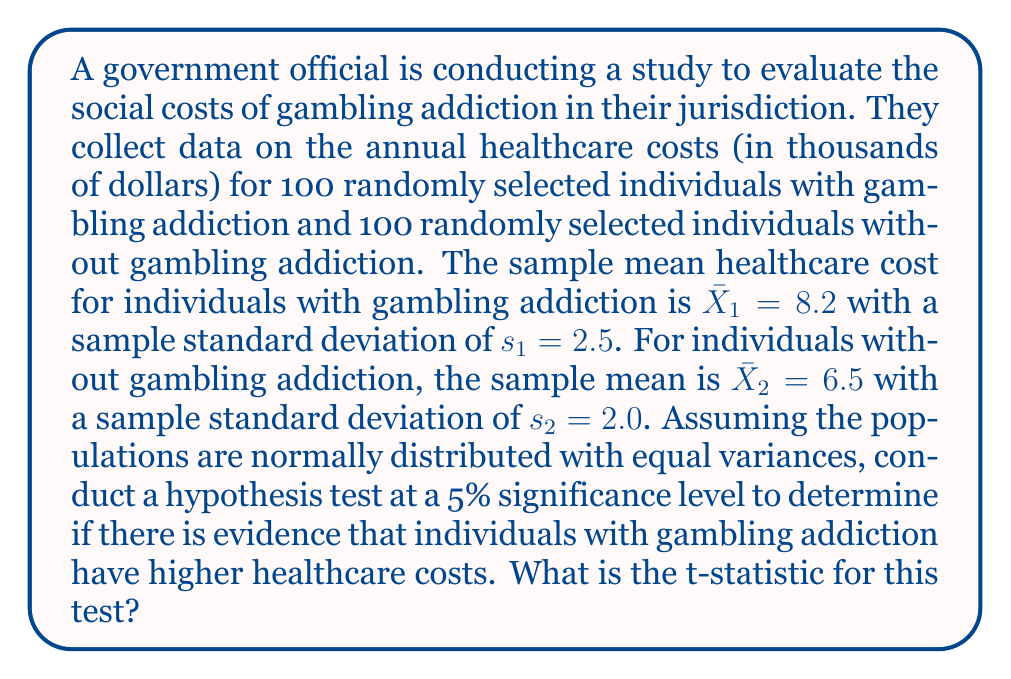Help me with this question. To conduct this hypothesis test, we'll follow these steps:

1) First, let's state our hypotheses:
   $H_0: \mu_1 - \mu_2 = 0$ (There's no difference in healthcare costs)
   $H_a: \mu_1 - \mu_2 > 0$ (Healthcare costs are higher for individuals with gambling addiction)

2) We'll use a two-sample t-test with pooled variance, as we're assuming equal population variances.

3) The formula for the t-statistic is:

   $$t = \frac{(\bar{X}_1 - \bar{X}_2) - (\mu_1 - \mu_2)_0}{\sqrt{s_p^2(\frac{1}{n_1} + \frac{1}{n_2})}}$$

   Where $s_p^2$ is the pooled variance:

   $$s_p^2 = \frac{(n_1 - 1)s_1^2 + (n_2 - 1)s_2^2}{n_1 + n_2 - 2}$$

4) Let's calculate the pooled variance:

   $$s_p^2 = \frac{(100 - 1)(2.5)^2 + (100 - 1)(2.0)^2}{100 + 100 - 2} = \frac{99(6.25) + 99(4)}{198} = \frac{1014.75}{198} = 5.125$$

5) Now we can calculate the t-statistic:

   $$t = \frac{(8.2 - 6.5) - 0}{\sqrt{5.125(\frac{1}{100} + \frac{1}{100})}} = \frac{1.7}{\sqrt{0.1025}} = \frac{1.7}{0.3202} = 5.3092$$

Therefore, the t-statistic for this test is approximately 5.3092.
Answer: The t-statistic for this hypothesis test is approximately 5.3092. 